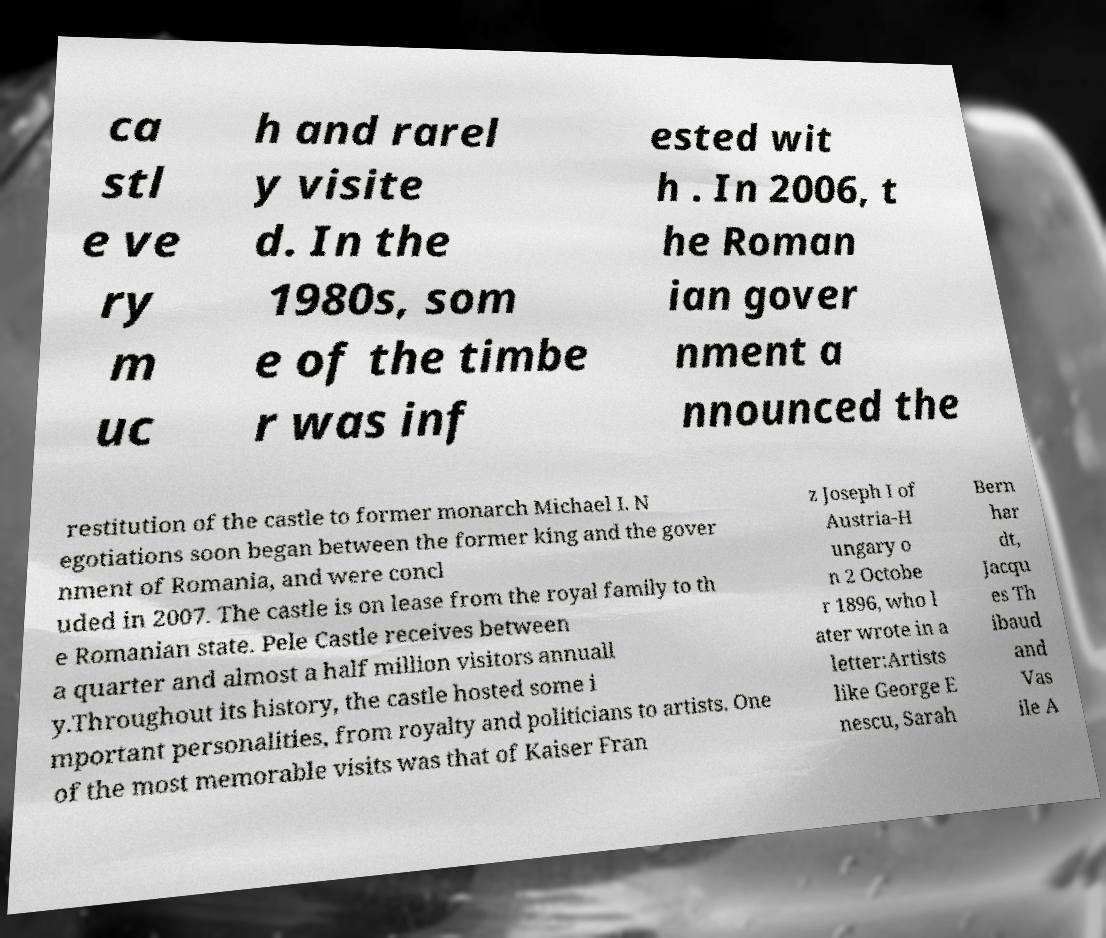Can you read and provide the text displayed in the image?This photo seems to have some interesting text. Can you extract and type it out for me? ca stl e ve ry m uc h and rarel y visite d. In the 1980s, som e of the timbe r was inf ested wit h . In 2006, t he Roman ian gover nment a nnounced the restitution of the castle to former monarch Michael I. N egotiations soon began between the former king and the gover nment of Romania, and were concl uded in 2007. The castle is on lease from the royal family to th e Romanian state. Pele Castle receives between a quarter and almost a half million visitors annuall y.Throughout its history, the castle hosted some i mportant personalities, from royalty and politicians to artists. One of the most memorable visits was that of Kaiser Fran z Joseph I of Austria-H ungary o n 2 Octobe r 1896, who l ater wrote in a letter:Artists like George E nescu, Sarah Bern har dt, Jacqu es Th ibaud and Vas ile A 